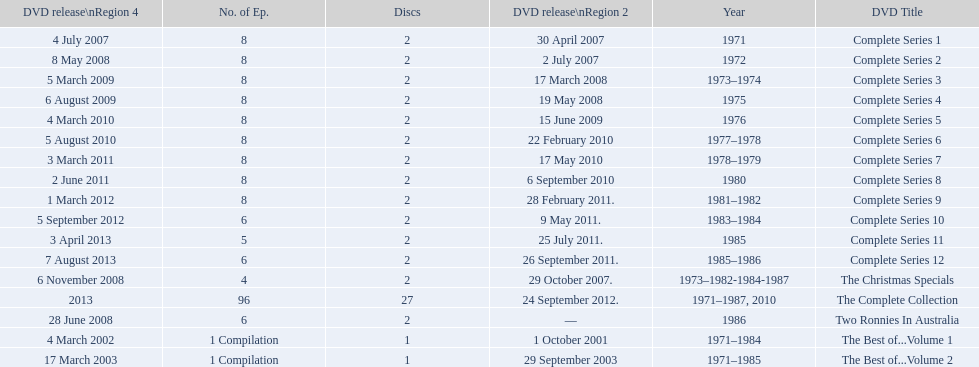The television show "the two ronnies" ran for a total of how many seasons? 12. 